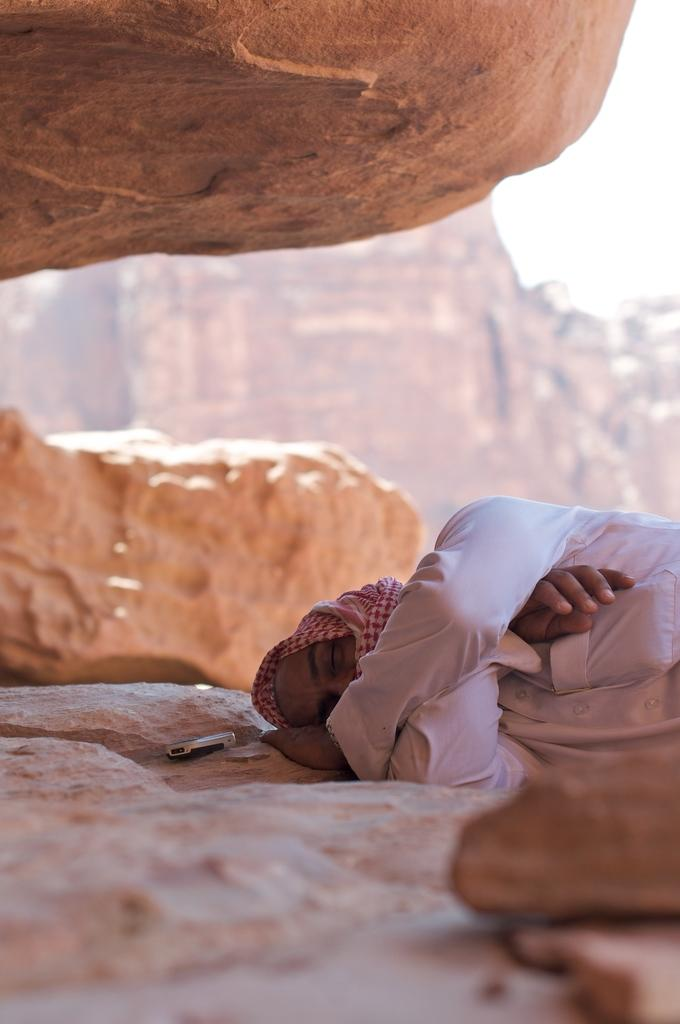What is the person in the image doing? The person is laying on a rock in the image. What is the person wearing? The person is wearing a white dress. What object is beside the person? There is a mobile beside the person. What can be seen in the distance in the image? There are hills visible in the background of the image. What level of division is present in the coil seen in the image? There is no coil present in the image, so it is not possible to determine the level of division. 